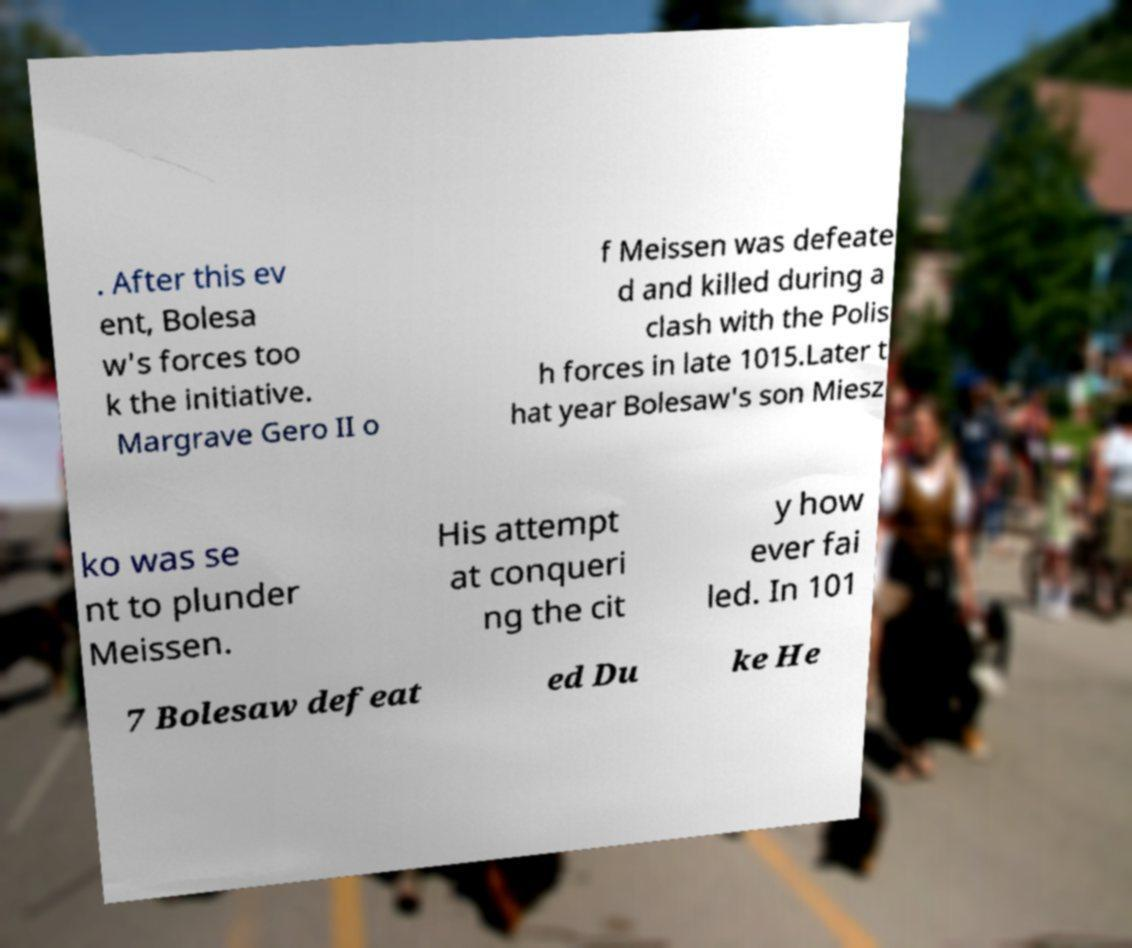What messages or text are displayed in this image? I need them in a readable, typed format. . After this ev ent, Bolesa w's forces too k the initiative. Margrave Gero II o f Meissen was defeate d and killed during a clash with the Polis h forces in late 1015.Later t hat year Bolesaw's son Miesz ko was se nt to plunder Meissen. His attempt at conqueri ng the cit y how ever fai led. In 101 7 Bolesaw defeat ed Du ke He 